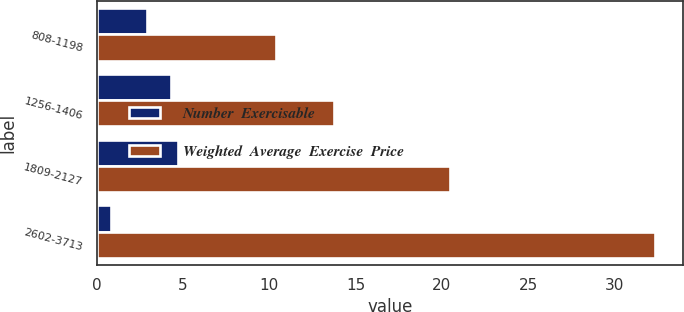Convert chart to OTSL. <chart><loc_0><loc_0><loc_500><loc_500><stacked_bar_chart><ecel><fcel>808-1198<fcel>1256-1406<fcel>1809-2127<fcel>2602-3713<nl><fcel>Number  Exercisable<fcel>2.9<fcel>4.3<fcel>4.7<fcel>0.8<nl><fcel>Weighted  Average  Exercise  Price<fcel>10.41<fcel>13.76<fcel>20.5<fcel>32.38<nl></chart> 